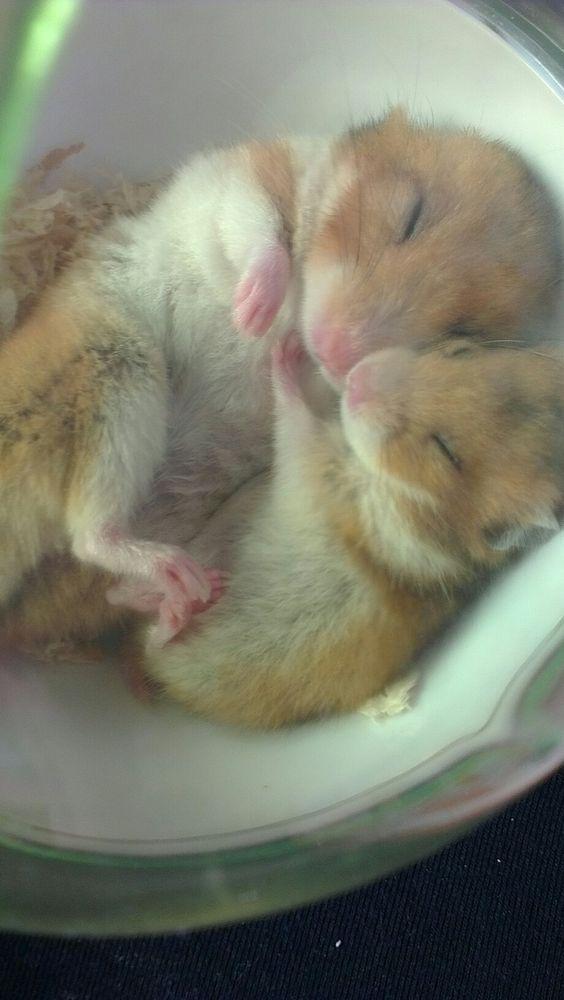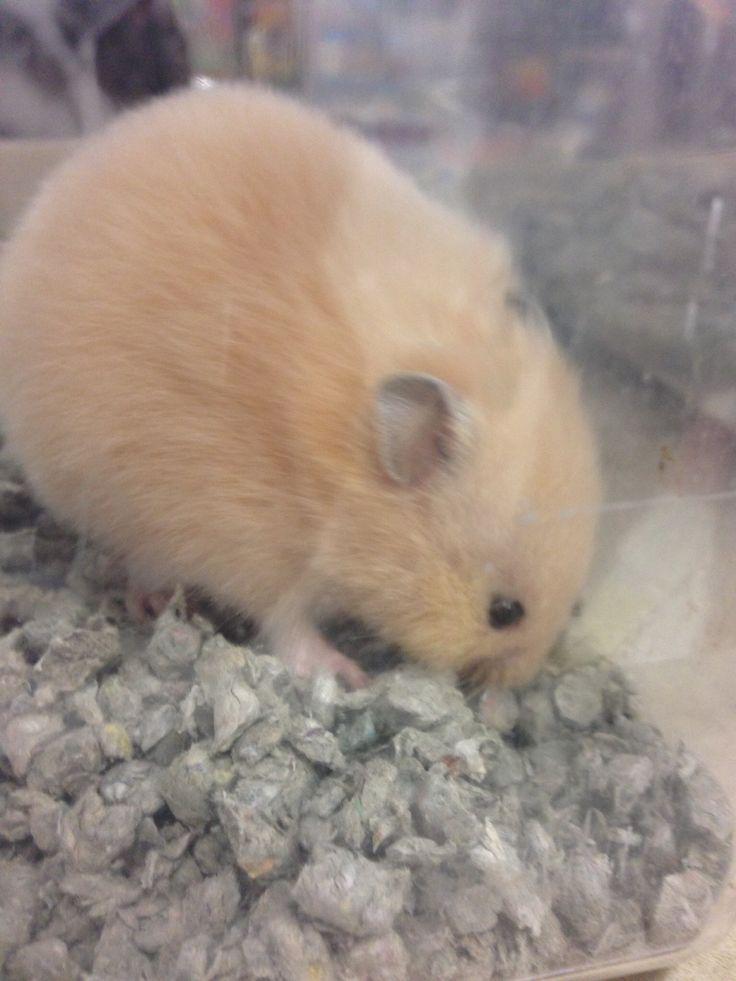The first image is the image on the left, the second image is the image on the right. For the images displayed, is the sentence "The left image shows two hamsters sleeping side-by-side with their eyes shut and paws facing upward." factually correct? Answer yes or no. Yes. The first image is the image on the left, the second image is the image on the right. Assess this claim about the two images: "Some of the hamsters are asleep.". Correct or not? Answer yes or no. Yes. 